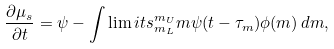Convert formula to latex. <formula><loc_0><loc_0><loc_500><loc_500>\frac { \partial \mu _ { s } } { \partial t } = \psi - \int \lim i t s _ { m _ { L } } ^ { m _ { U } } { m \psi ( t - \tau _ { m } ) \phi ( m ) \, d m } ,</formula> 